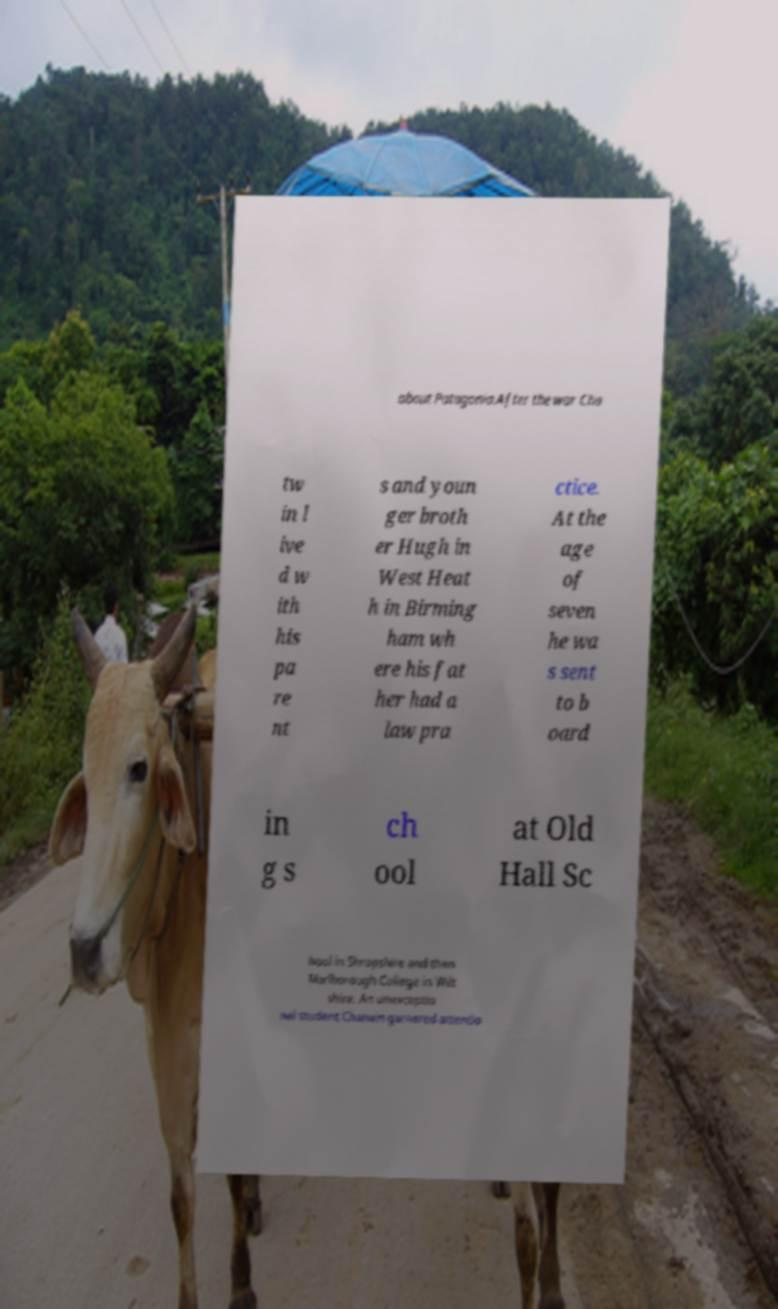Please read and relay the text visible in this image. What does it say? about Patagonia.After the war Cha tw in l ive d w ith his pa re nt s and youn ger broth er Hugh in West Heat h in Birming ham wh ere his fat her had a law pra ctice. At the age of seven he wa s sent to b oard in g s ch ool at Old Hall Sc hool in Shropshire and then Marlborough College in Wilt shire. An unexceptio nal student Chatwin garnered attentio 